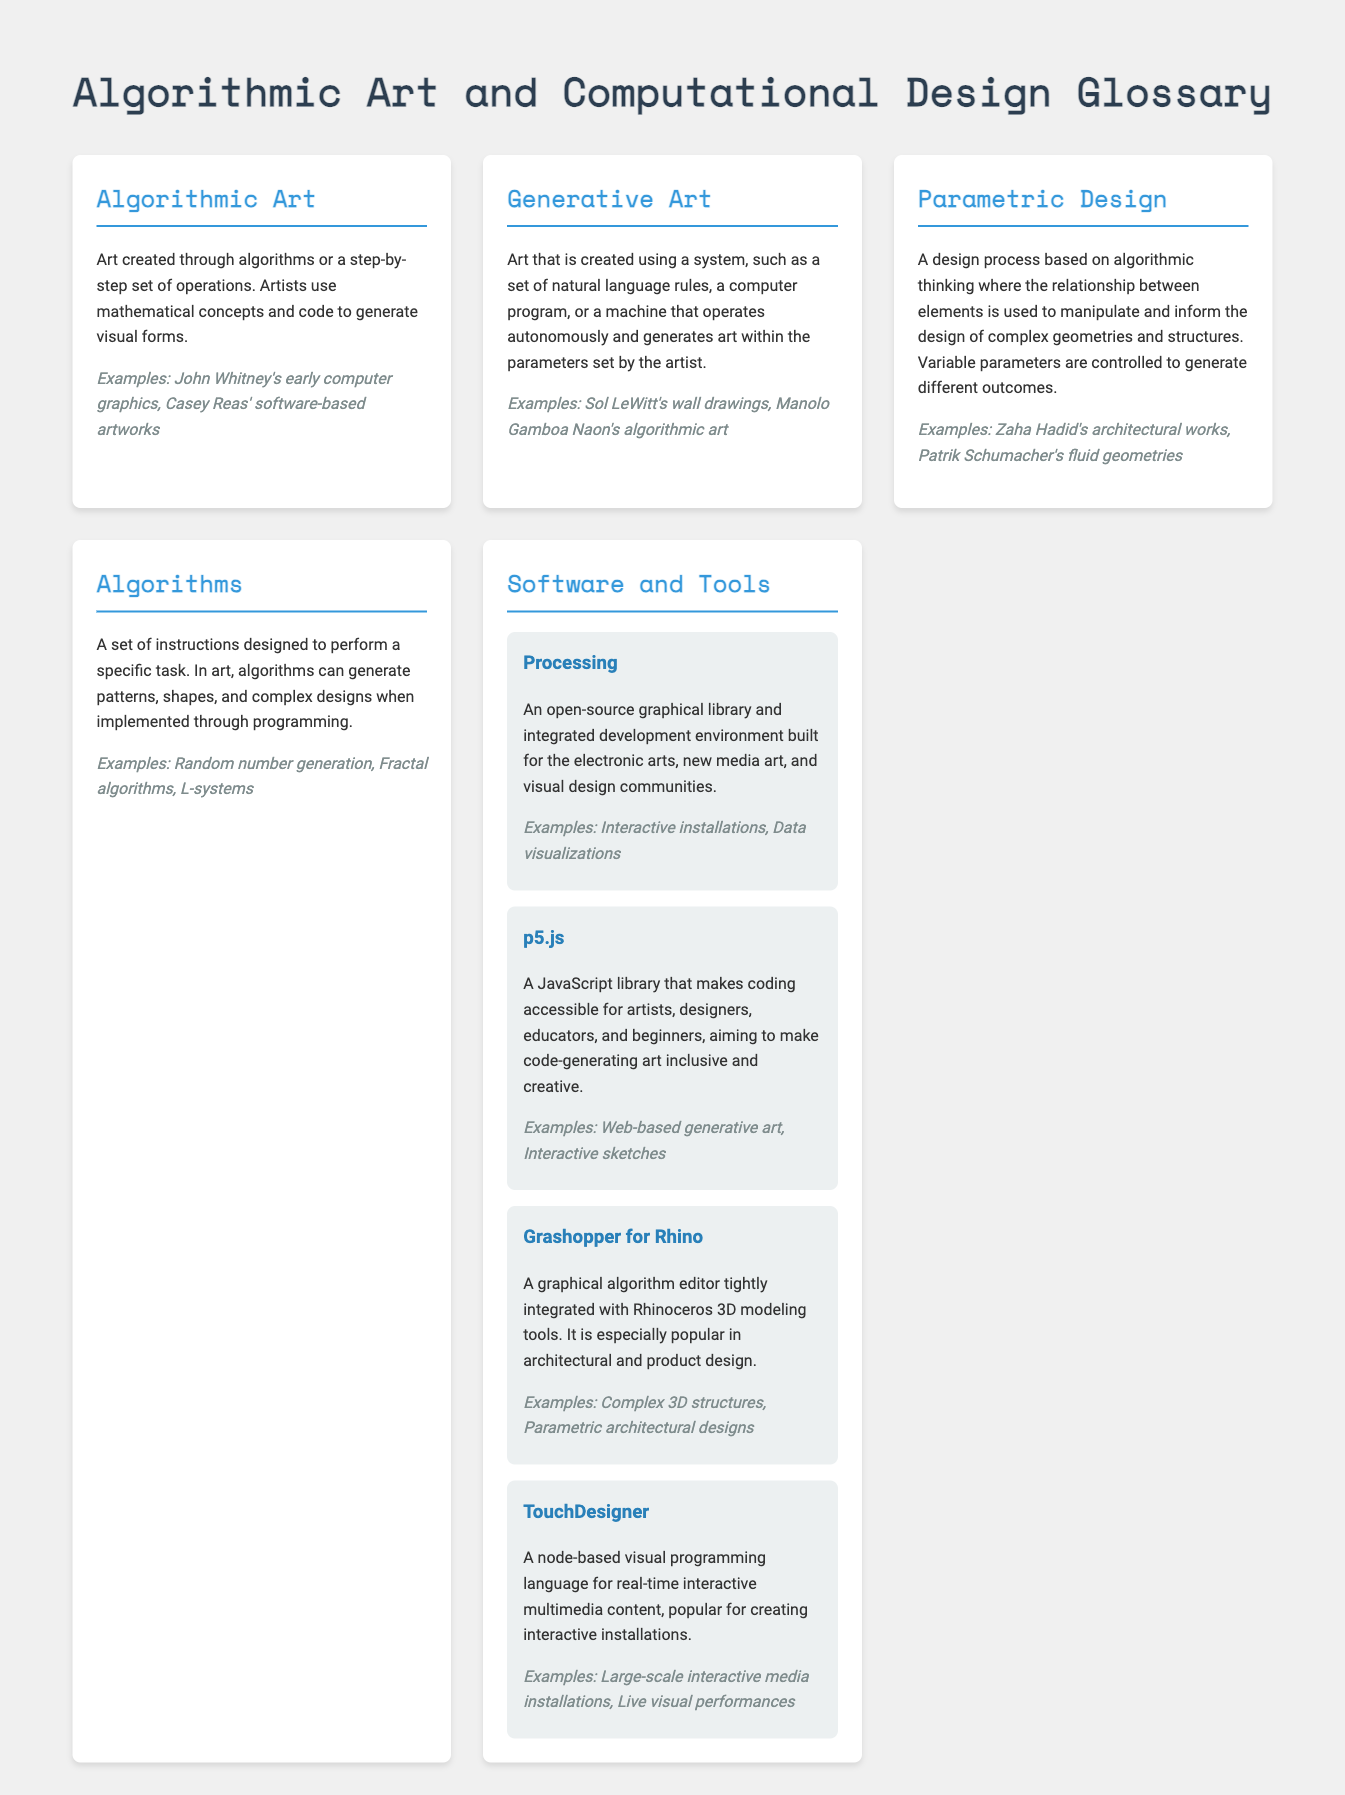What is algorithmic art? Algorithmic art is defined in the document as art created through algorithms or a step-by-step set of operations.
Answer: Art created through algorithms Who is an artist known for early computer graphics? John Whitney is mentioned in the examples as an artist known for early computer graphics.
Answer: John Whitney What type of design is based on variable parameters? Parametric design is the design process that is based on variable parameters to generate different outcomes.
Answer: Parametric design What software is described as an open-source graphical library? Processing is mentioned as an open-source graphical library.
Answer: Processing Which tool is used for real-time interactive multimedia content? TouchDesigner is referenced as a tool used for real-time interactive multimedia content.
Answer: TouchDesigner How does generative art operate? Generative art is created using a system, such as a set of natural language rules or a computer program.
Answer: A system What is a common example of algorithms in art? Random number generation is listed as a common algorithmic example in art.
Answer: Random number generation Which artist is associated with fluid geometries? Patrik Schumacher is mentioned as an artist associated with fluid geometries in parametric design examples.
Answer: Patrik Schumacher What is the focus of the document? The focus of the document is on the intersection of art and technology through algorithmic art and computational design.
Answer: Intersection of art and technology 